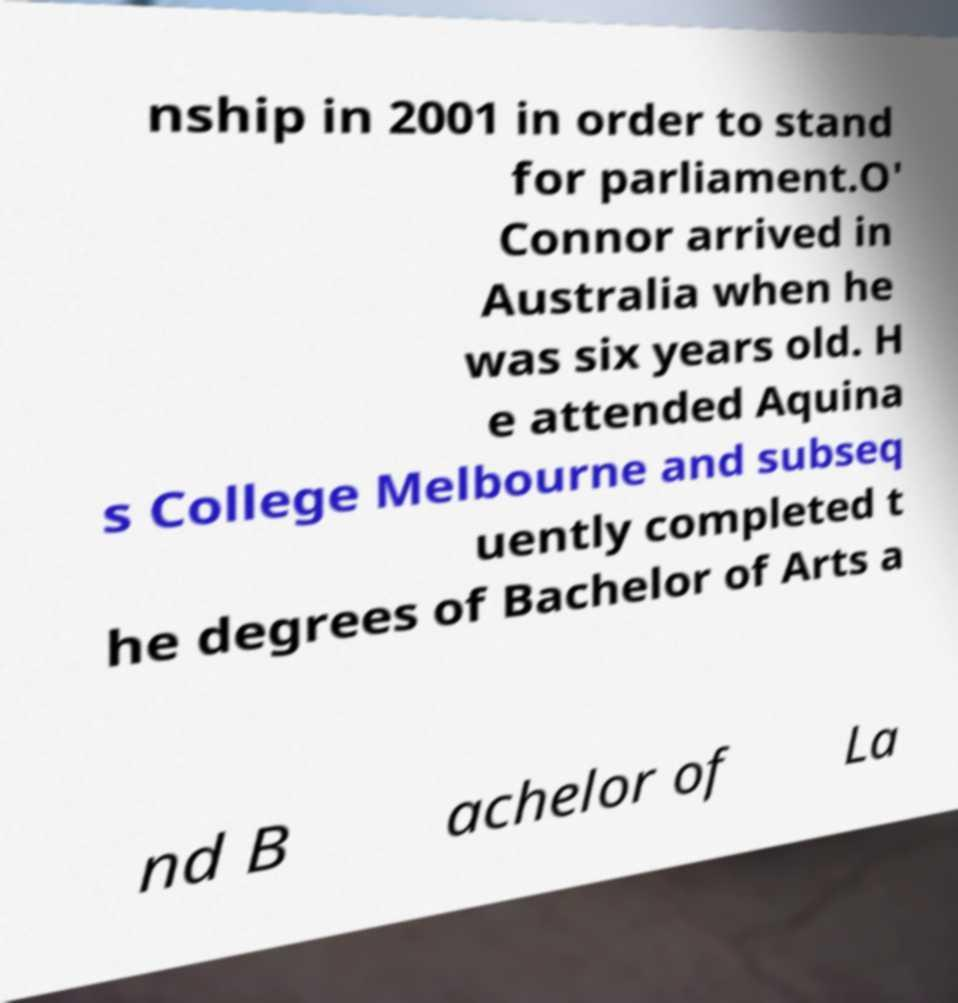Could you assist in decoding the text presented in this image and type it out clearly? nship in 2001 in order to stand for parliament.O' Connor arrived in Australia when he was six years old. H e attended Aquina s College Melbourne and subseq uently completed t he degrees of Bachelor of Arts a nd B achelor of La 